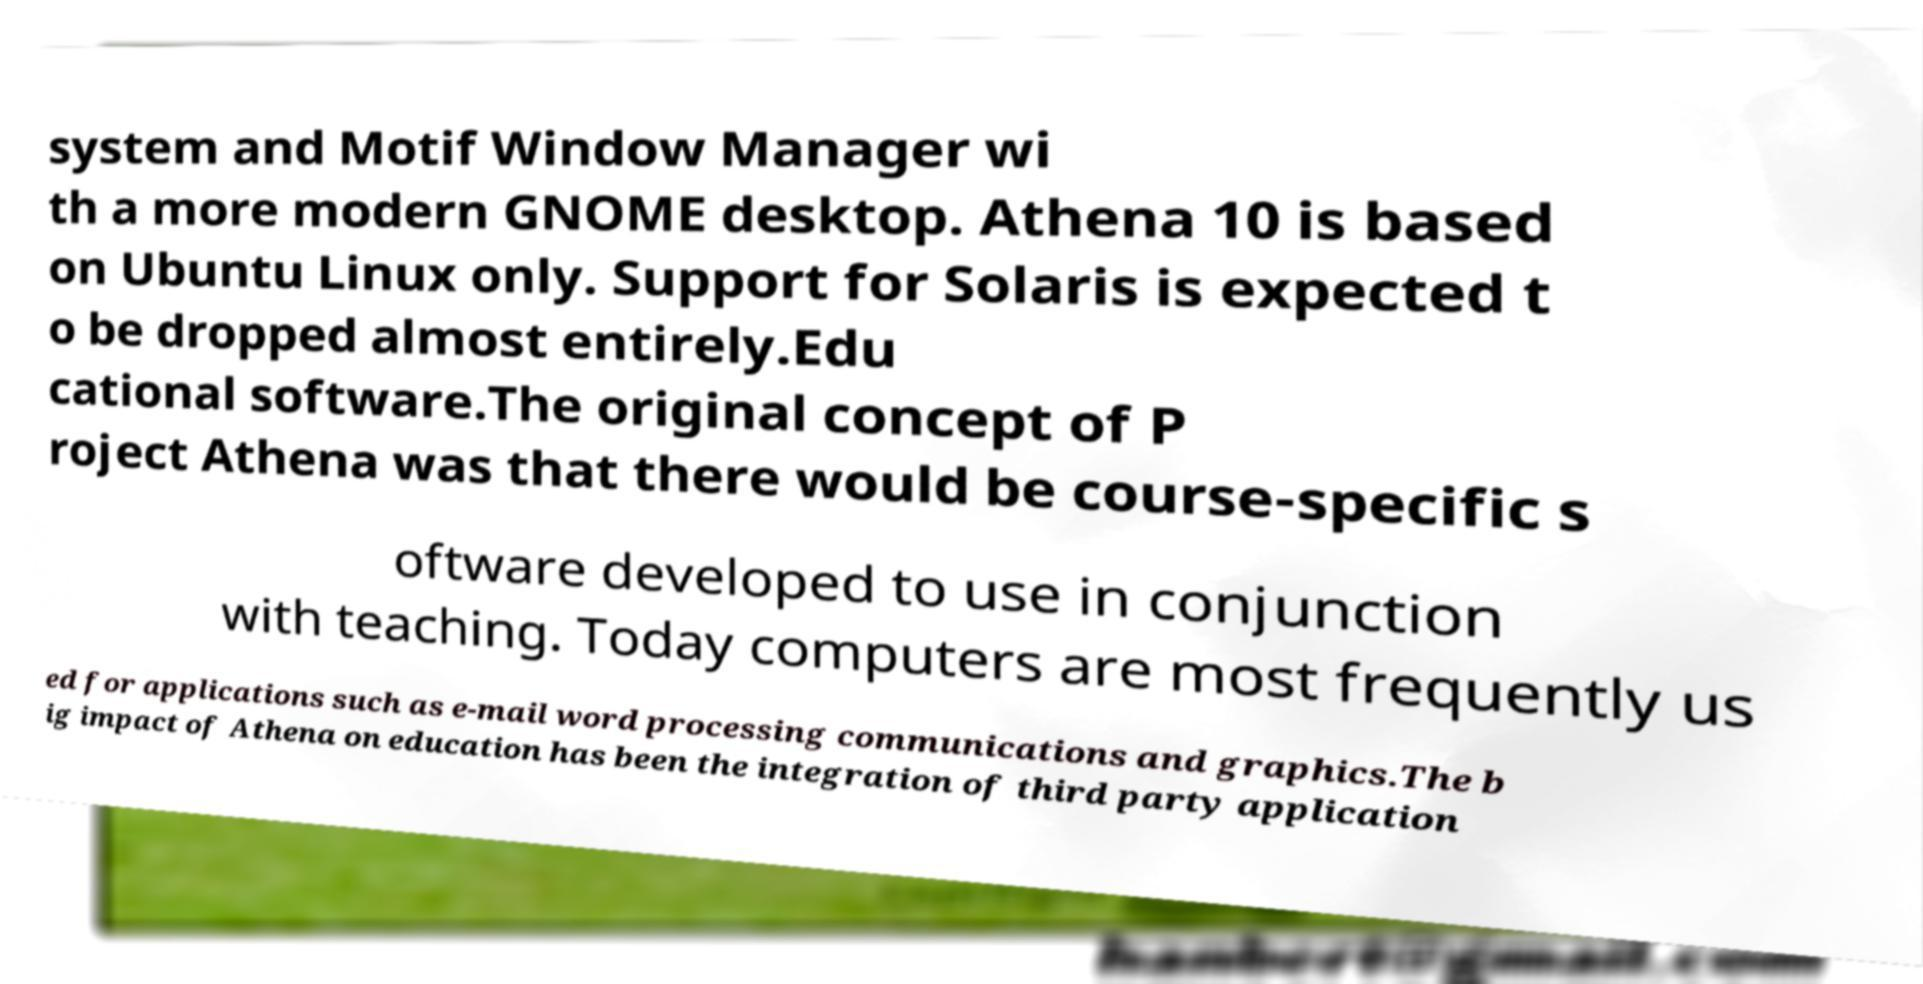Could you assist in decoding the text presented in this image and type it out clearly? system and Motif Window Manager wi th a more modern GNOME desktop. Athena 10 is based on Ubuntu Linux only. Support for Solaris is expected t o be dropped almost entirely.Edu cational software.The original concept of P roject Athena was that there would be course-specific s oftware developed to use in conjunction with teaching. Today computers are most frequently us ed for applications such as e-mail word processing communications and graphics.The b ig impact of Athena on education has been the integration of third party application 